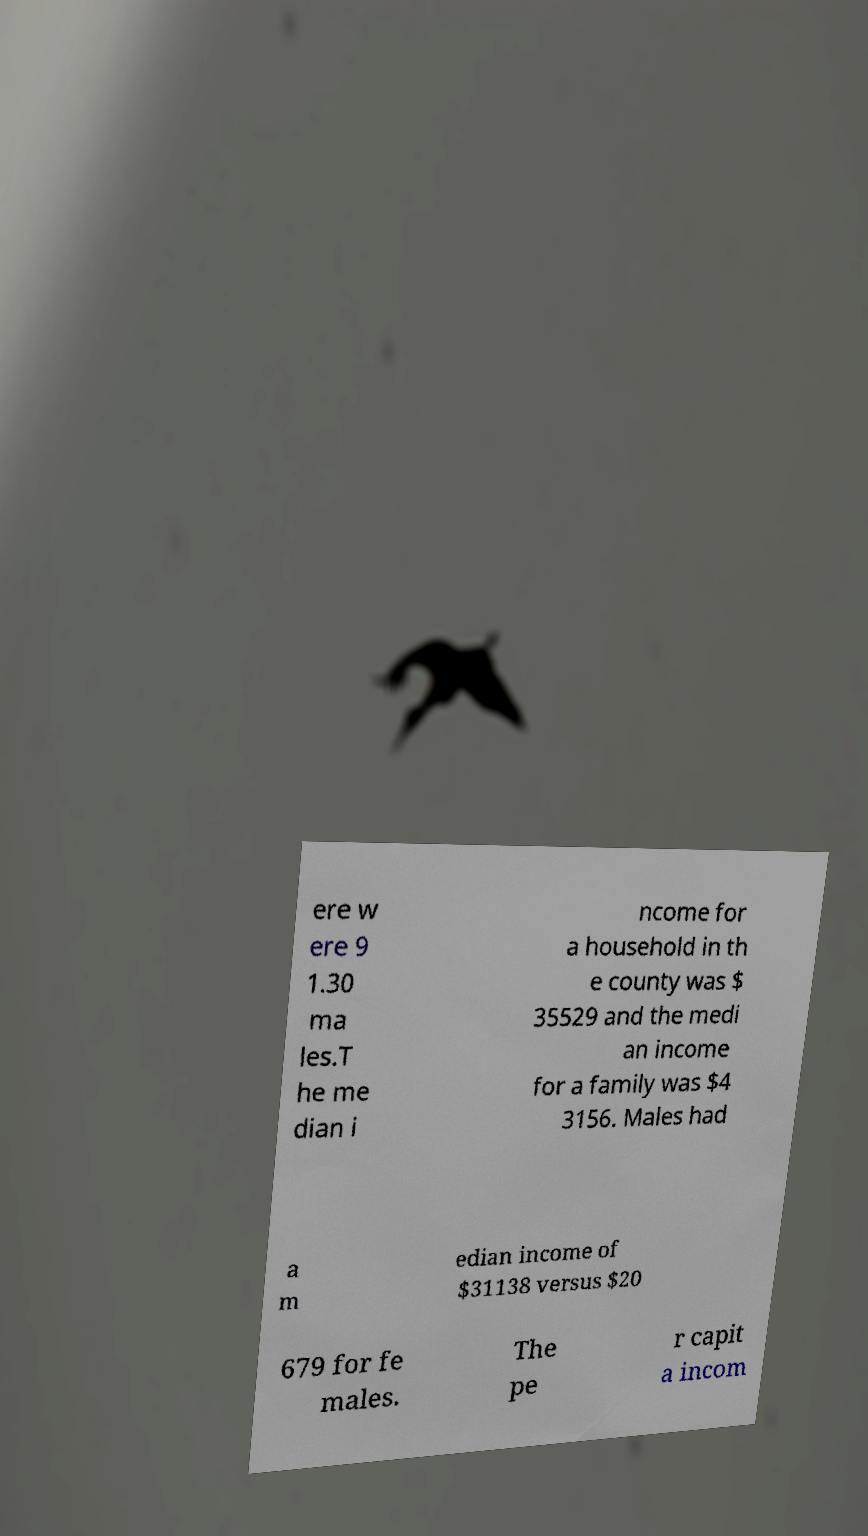There's text embedded in this image that I need extracted. Can you transcribe it verbatim? ere w ere 9 1.30 ma les.T he me dian i ncome for a household in th e county was $ 35529 and the medi an income for a family was $4 3156. Males had a m edian income of $31138 versus $20 679 for fe males. The pe r capit a incom 